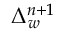<formula> <loc_0><loc_0><loc_500><loc_500>\Delta _ { w } ^ { n + 1 }</formula> 